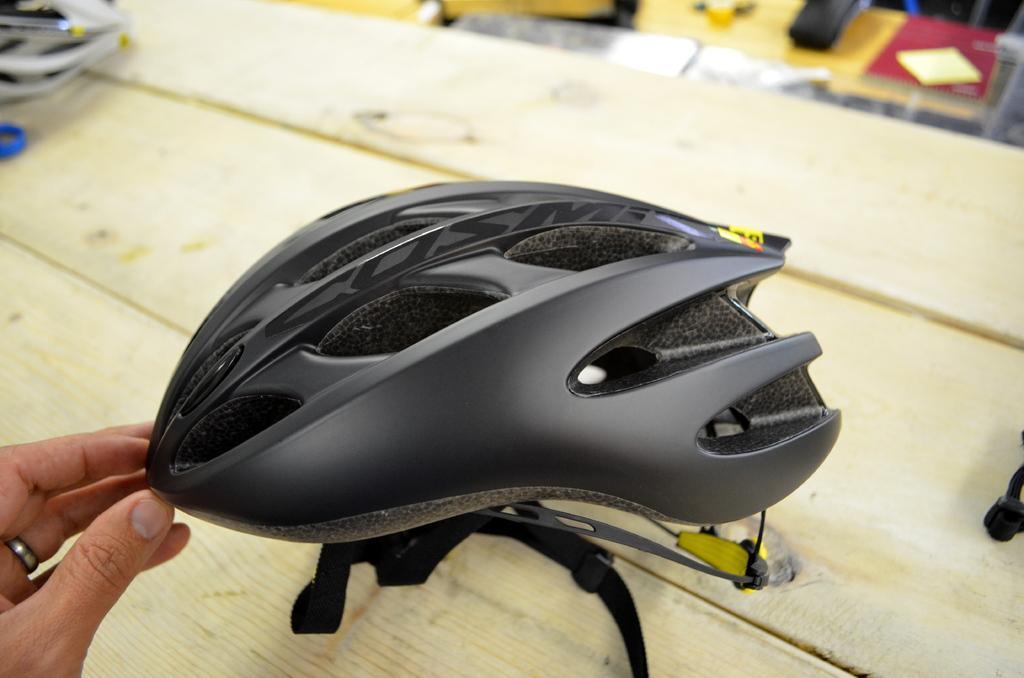How would you summarize this image in a sentence or two? In the picture I can see a black color helmet and some other objects on a wooden a table. I can also see a person's hand. 